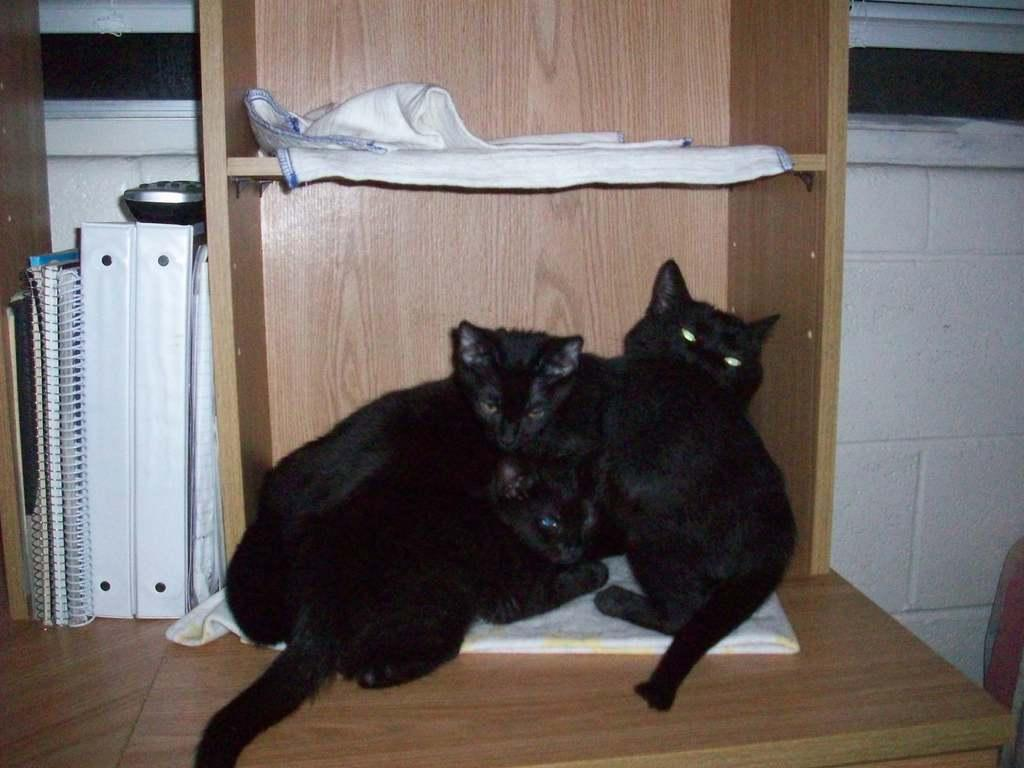What animals are on the cloth in the image? There are cats on a cloth in the image. What else can be seen in the image besides the cats? Clothes, books, and a remote on a wooden surface are visible in the image. What is the background of the image? The background of the image includes a white wall. What type of wound can be seen on the cats in the image? There are no wounds visible on the cats in the image. How much eggnog is being served in the image? There is no eggnog present in the image. 